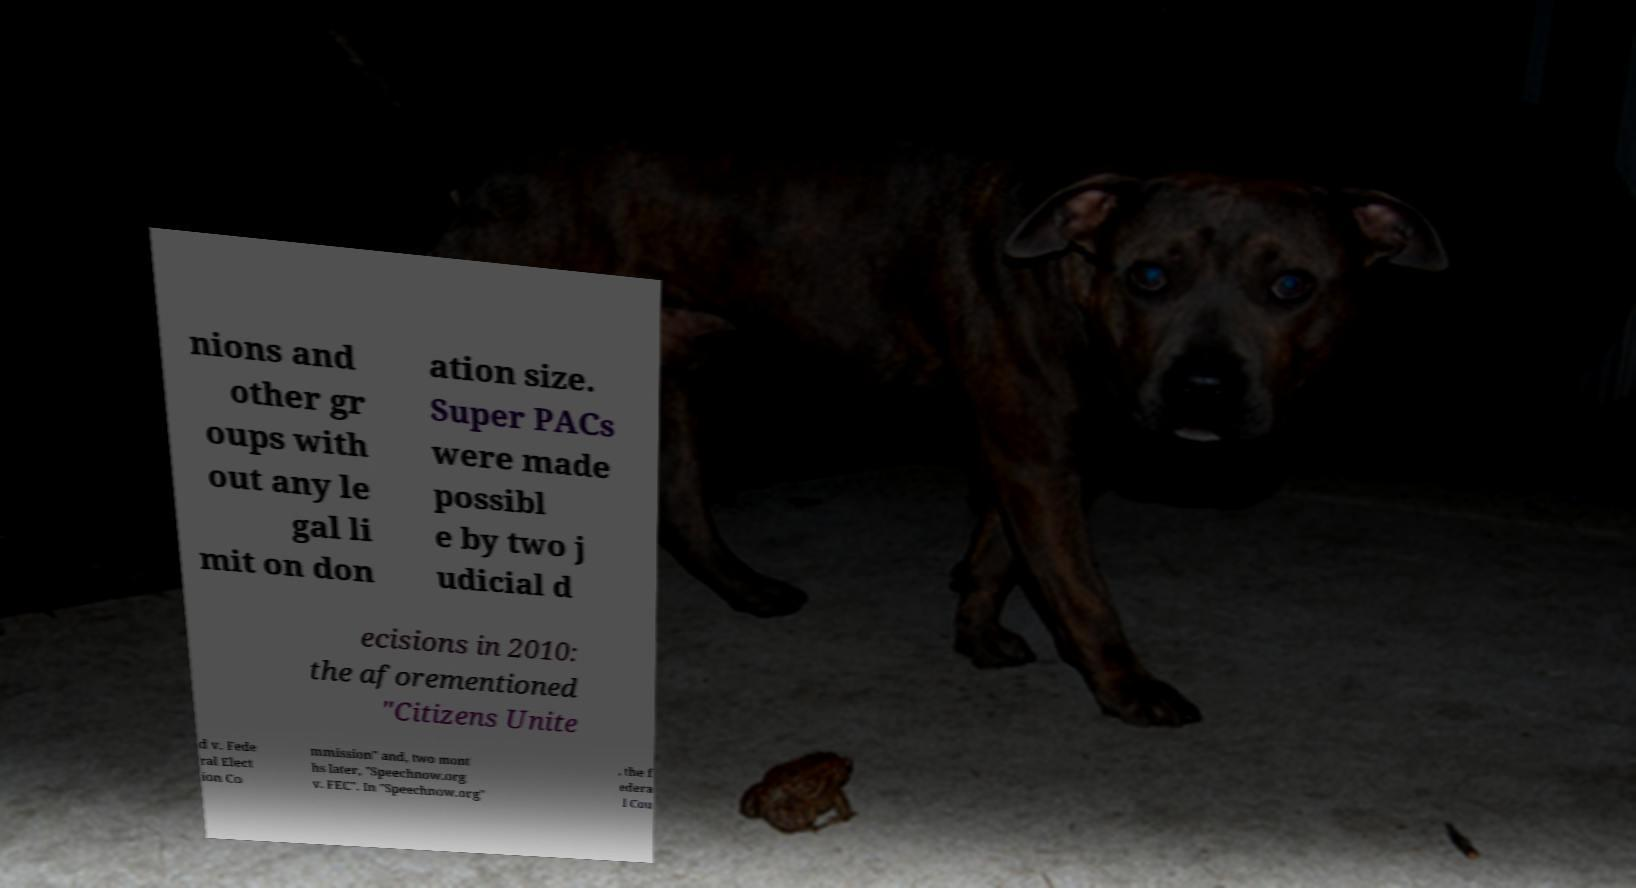Please read and relay the text visible in this image. What does it say? nions and other gr oups with out any le gal li mit on don ation size. Super PACs were made possibl e by two j udicial d ecisions in 2010: the aforementioned "Citizens Unite d v. Fede ral Elect ion Co mmission" and, two mont hs later, "Speechnow.org v. FEC". In "Speechnow.org" , the f edera l Cou 